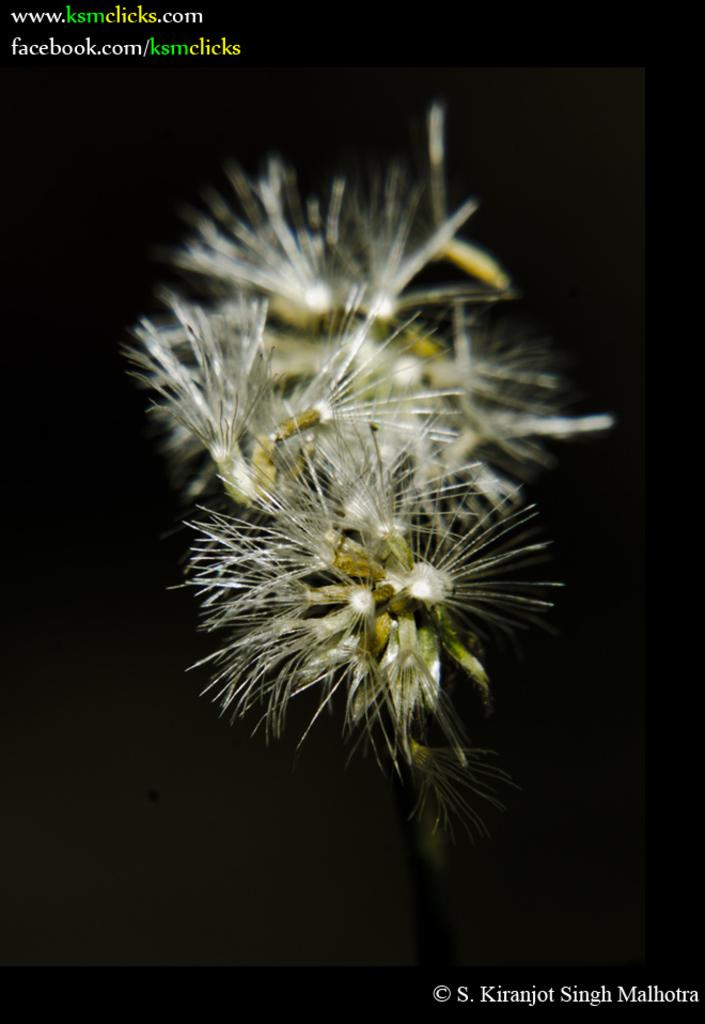What is the main object in the image? There is a screen in the image. What can be seen on the screen? The screen displays plants. What type of story is being told on the screen? There is no story being told on the screen; it displays plants. Can you see a battle taking place on the screen? There is no battle depicted on the screen; it displays plants. 